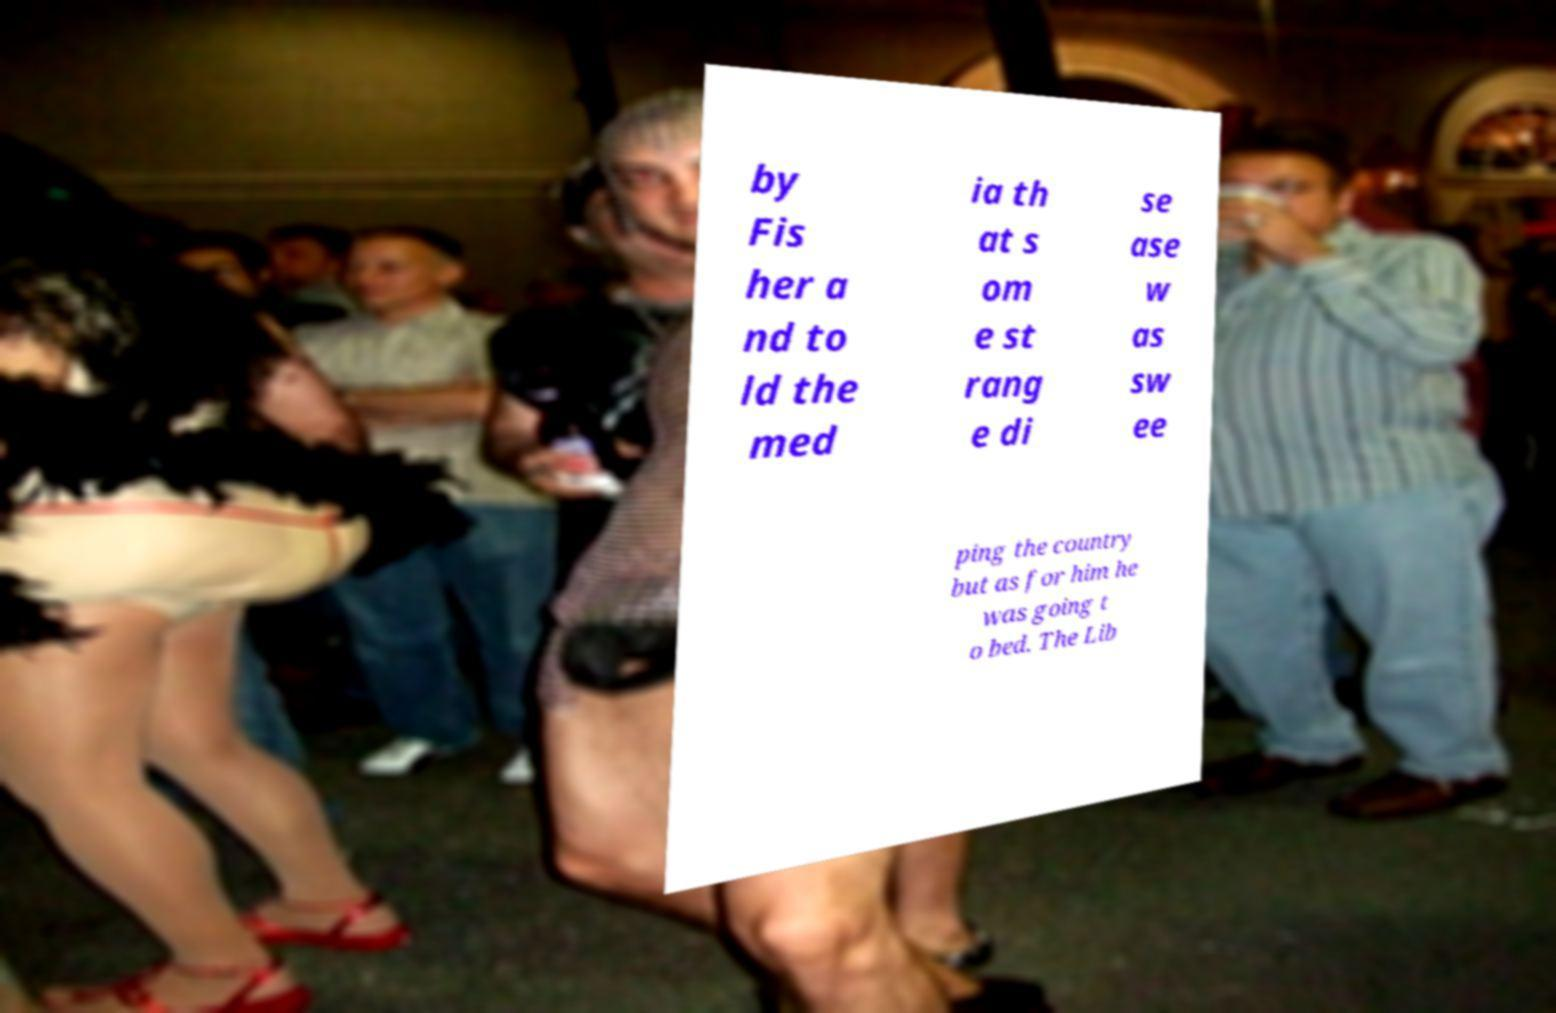Can you accurately transcribe the text from the provided image for me? by Fis her a nd to ld the med ia th at s om e st rang e di se ase w as sw ee ping the country but as for him he was going t o bed. The Lib 